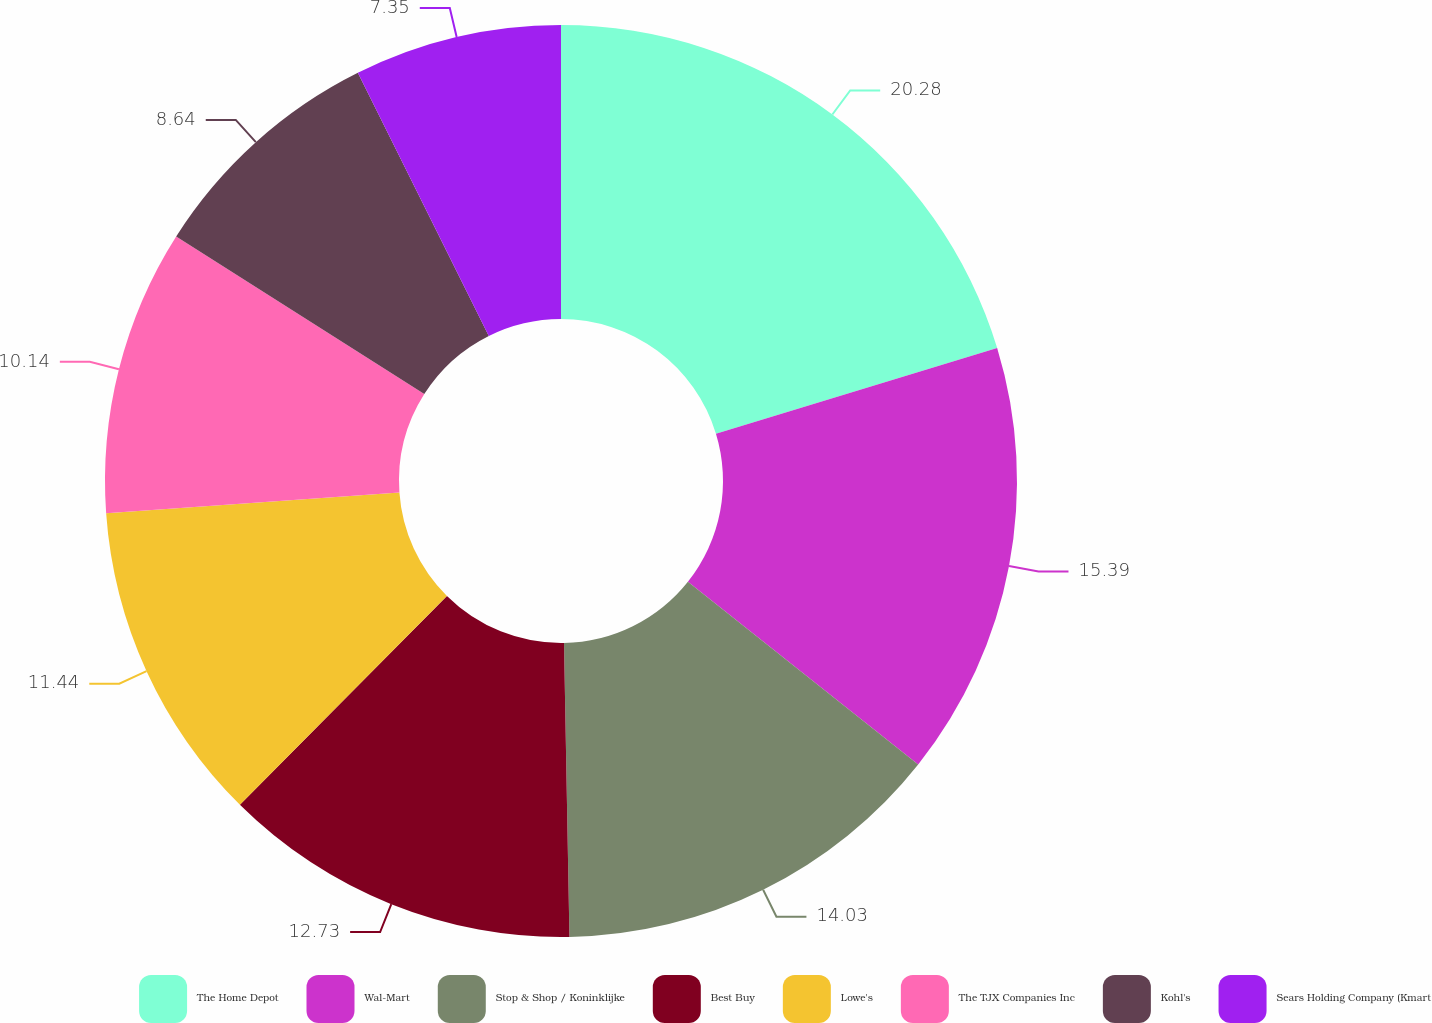Convert chart to OTSL. <chart><loc_0><loc_0><loc_500><loc_500><pie_chart><fcel>The Home Depot<fcel>Wal-Mart<fcel>Stop & Shop / Koninklijke<fcel>Best Buy<fcel>Lowe's<fcel>The TJX Companies Inc<fcel>Kohl's<fcel>Sears Holding Company (Kmart<nl><fcel>20.29%<fcel>15.39%<fcel>14.03%<fcel>12.73%<fcel>11.44%<fcel>10.14%<fcel>8.64%<fcel>7.35%<nl></chart> 